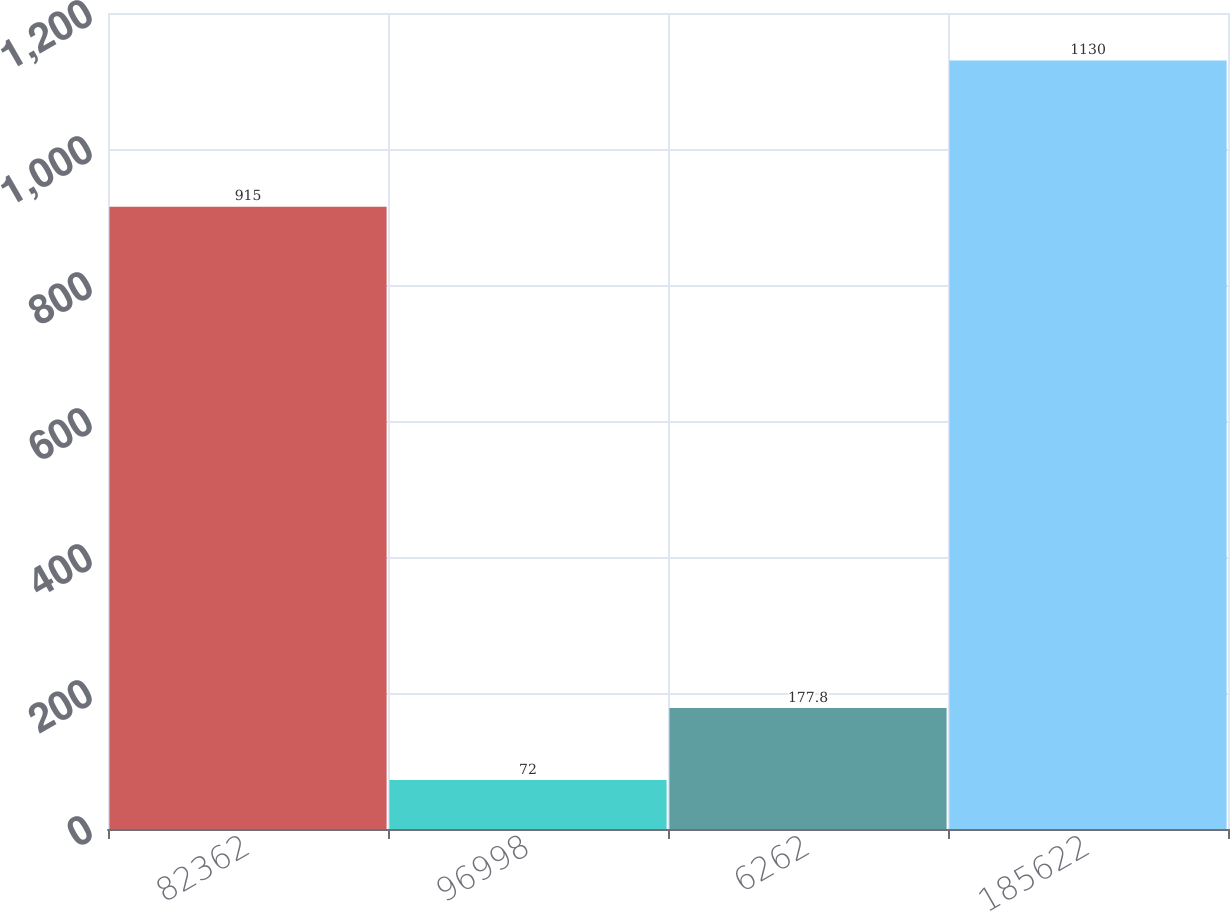Convert chart to OTSL. <chart><loc_0><loc_0><loc_500><loc_500><bar_chart><fcel>82362<fcel>96998<fcel>6262<fcel>185622<nl><fcel>915<fcel>72<fcel>177.8<fcel>1130<nl></chart> 